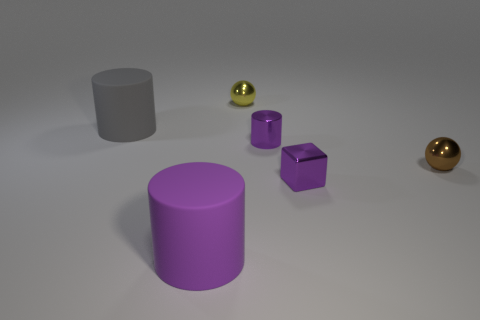How many other things are the same size as the yellow sphere?
Give a very brief answer. 3. There is a small ball that is in front of the matte object that is behind the big purple cylinder; what is it made of?
Ensure brevity in your answer.  Metal. Is the size of the metal cylinder the same as the gray cylinder that is behind the big purple matte cylinder?
Ensure brevity in your answer.  No. Are there any tiny blocks that have the same color as the shiny cylinder?
Your answer should be very brief. Yes. What number of small things are either rubber things or gray things?
Your answer should be compact. 0. What number of tiny objects are there?
Keep it short and to the point. 4. There is a purple object behind the brown metallic object; what is it made of?
Provide a short and direct response. Metal. There is a purple metal block; are there any big cylinders in front of it?
Offer a very short reply. Yes. Does the gray rubber cylinder have the same size as the metallic cylinder?
Provide a short and direct response. No. How many big purple cylinders are made of the same material as the large gray object?
Your answer should be very brief. 1. 